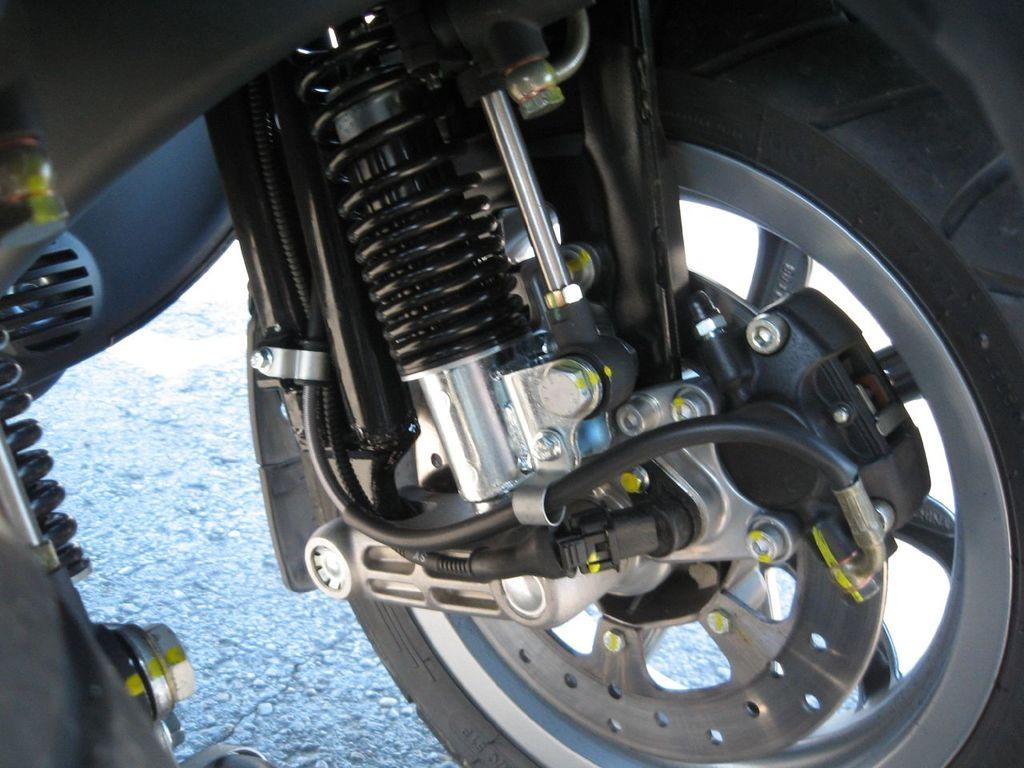What type of vehicle is partially visible in the image? There is a part of a vehicle in the image, but the specific type cannot be determined from the facts provided. What is one feature of the vehicle that can be seen? The vehicle has a wheel. What other objects can be seen in the image? There are wires and bolts visible in the image. Can you describe any other unspecified things in the image? Unfortunately, the facts provided do not give any details about the other unspecified things in the image. What type of bushes can be seen growing around the vehicle in the image? There is no mention of bushes in the image, so we cannot answer this question. Is there any writing visible on the vehicle in the image? The facts provided do not mention any writing on the vehicle, so we cannot answer this question. 